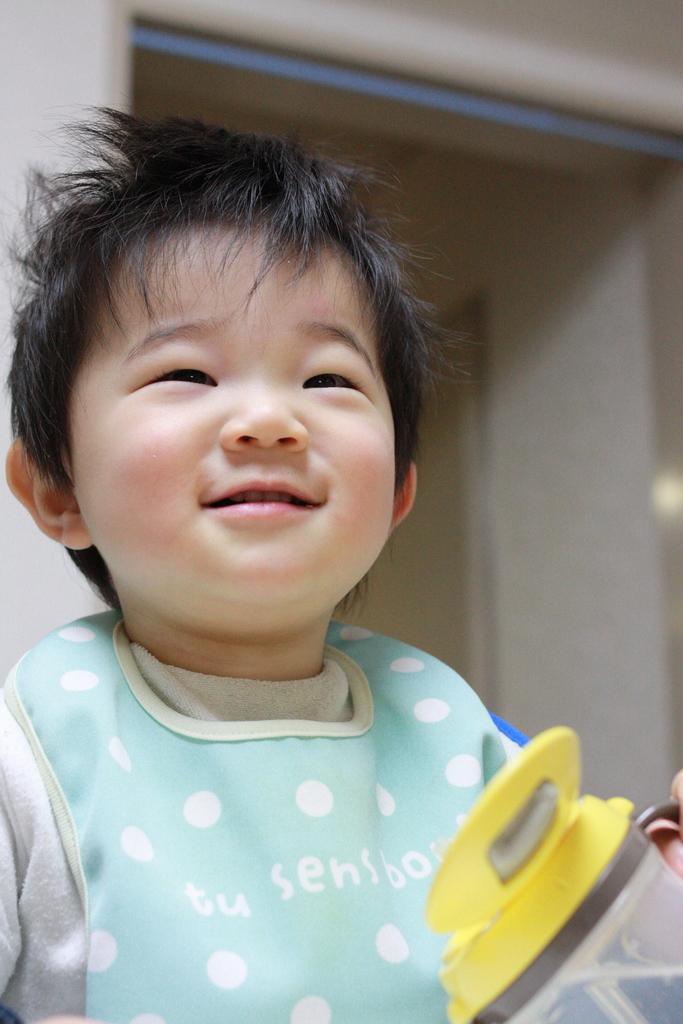In one or two sentences, can you explain what this image depicts? In this picture we can see a boy and a bottle. Behind the boy there is a wall. 